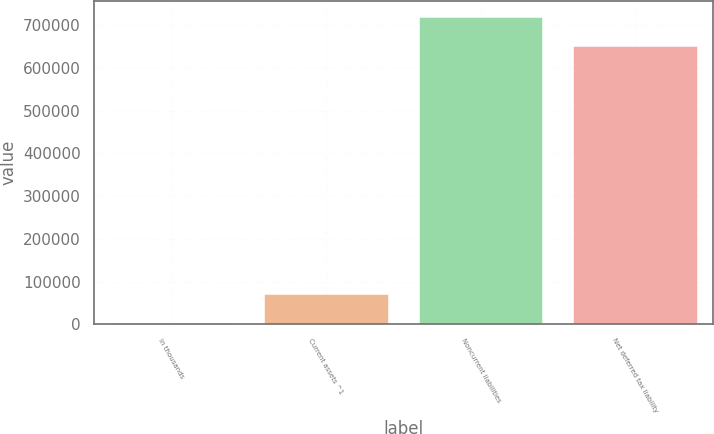<chart> <loc_0><loc_0><loc_500><loc_500><bar_chart><fcel>in thousands<fcel>Current assets ^1<fcel>Noncurrent liabilities<fcel>Net deferred tax liability<nl><fcel>2014<fcel>70926.3<fcel>720323<fcel>651411<nl></chart> 